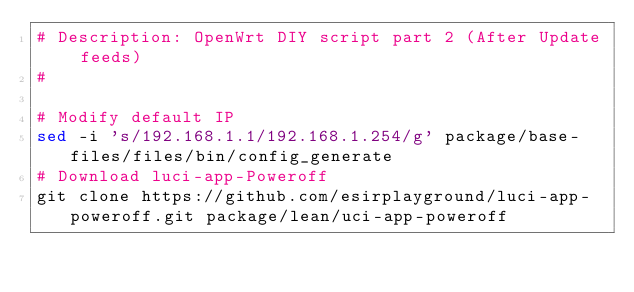Convert code to text. <code><loc_0><loc_0><loc_500><loc_500><_Bash_># Description: OpenWrt DIY script part 2 (After Update feeds)
#

# Modify default IP
sed -i 's/192.168.1.1/192.168.1.254/g' package/base-files/files/bin/config_generate
# Download luci-app-Poweroff
git clone https://github.com/esirplayground/luci-app-poweroff.git package/lean/uci-app-poweroff
</code> 